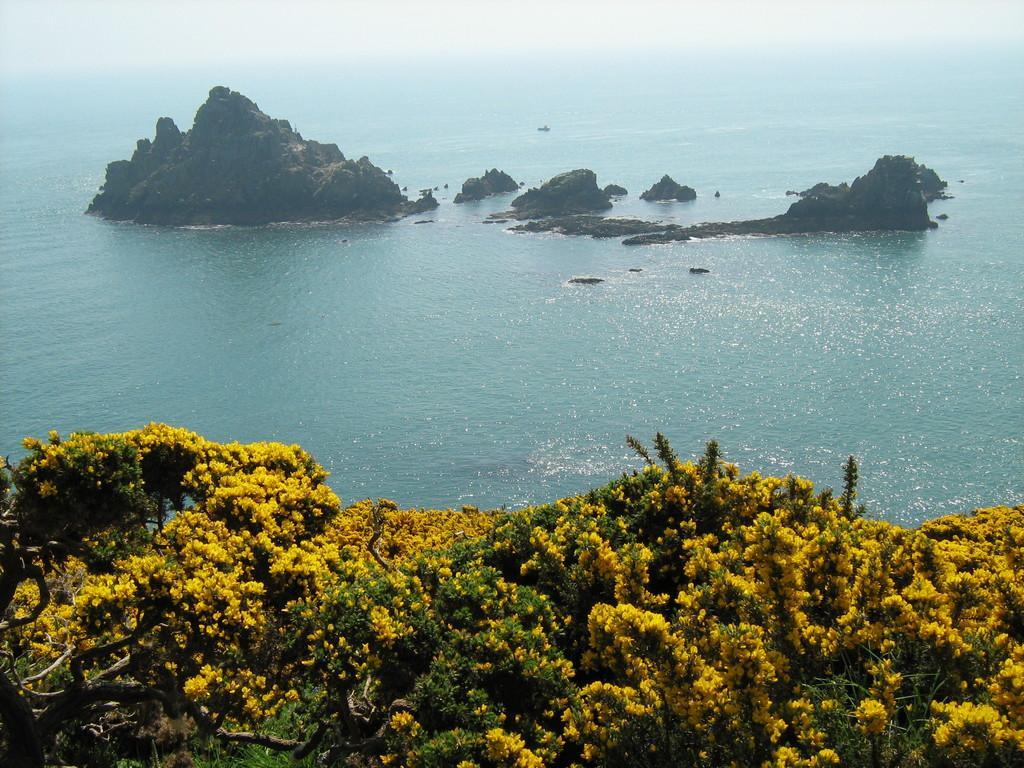Could you give a brief overview of what you see in this image? In this picture we can see trees with flowers and on the water we can see rocks. 